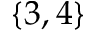<formula> <loc_0><loc_0><loc_500><loc_500>\{ 3 , 4 \}</formula> 